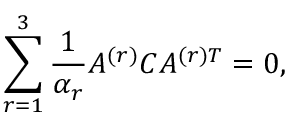<formula> <loc_0><loc_0><loc_500><loc_500>\sum _ { r = 1 } ^ { 3 } { \frac { 1 } { \alpha _ { r } } } A ^ { ( r ) } C A ^ { ( r ) T } = 0 ,</formula> 